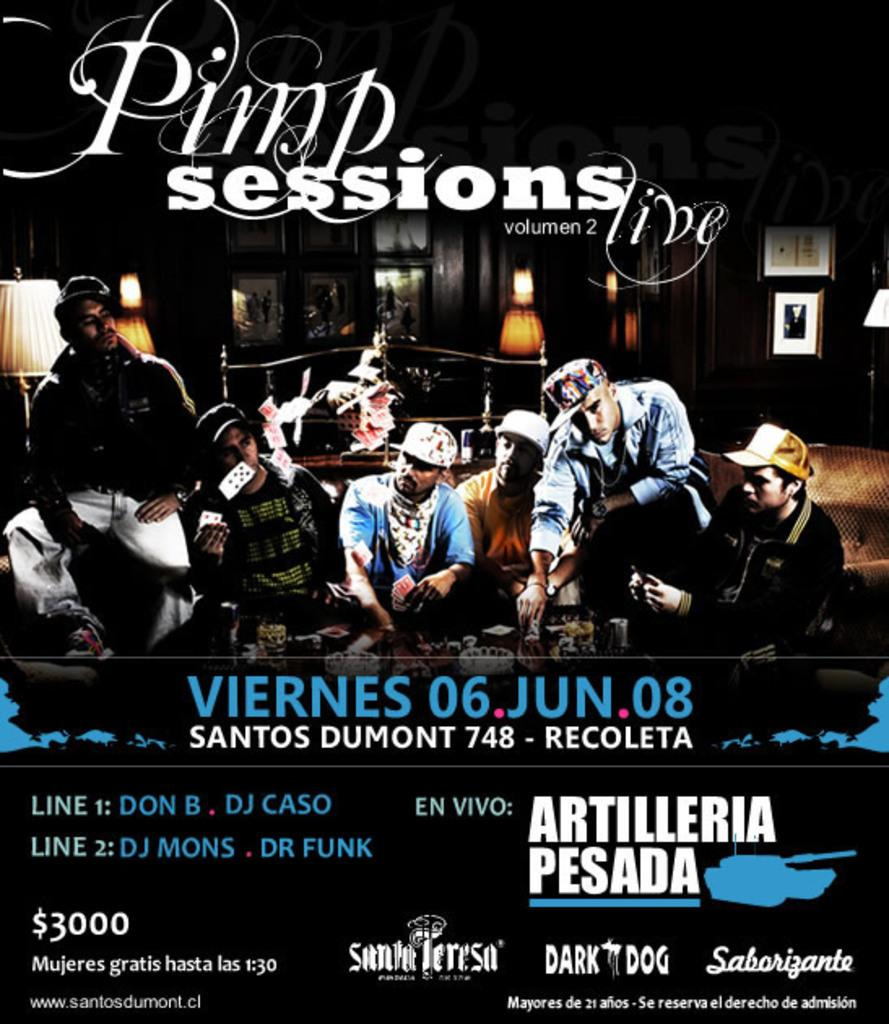Provide a one-sentence caption for the provided image. A poster advertises the "Pimp Sessions," taking place on June 6, 2008. 